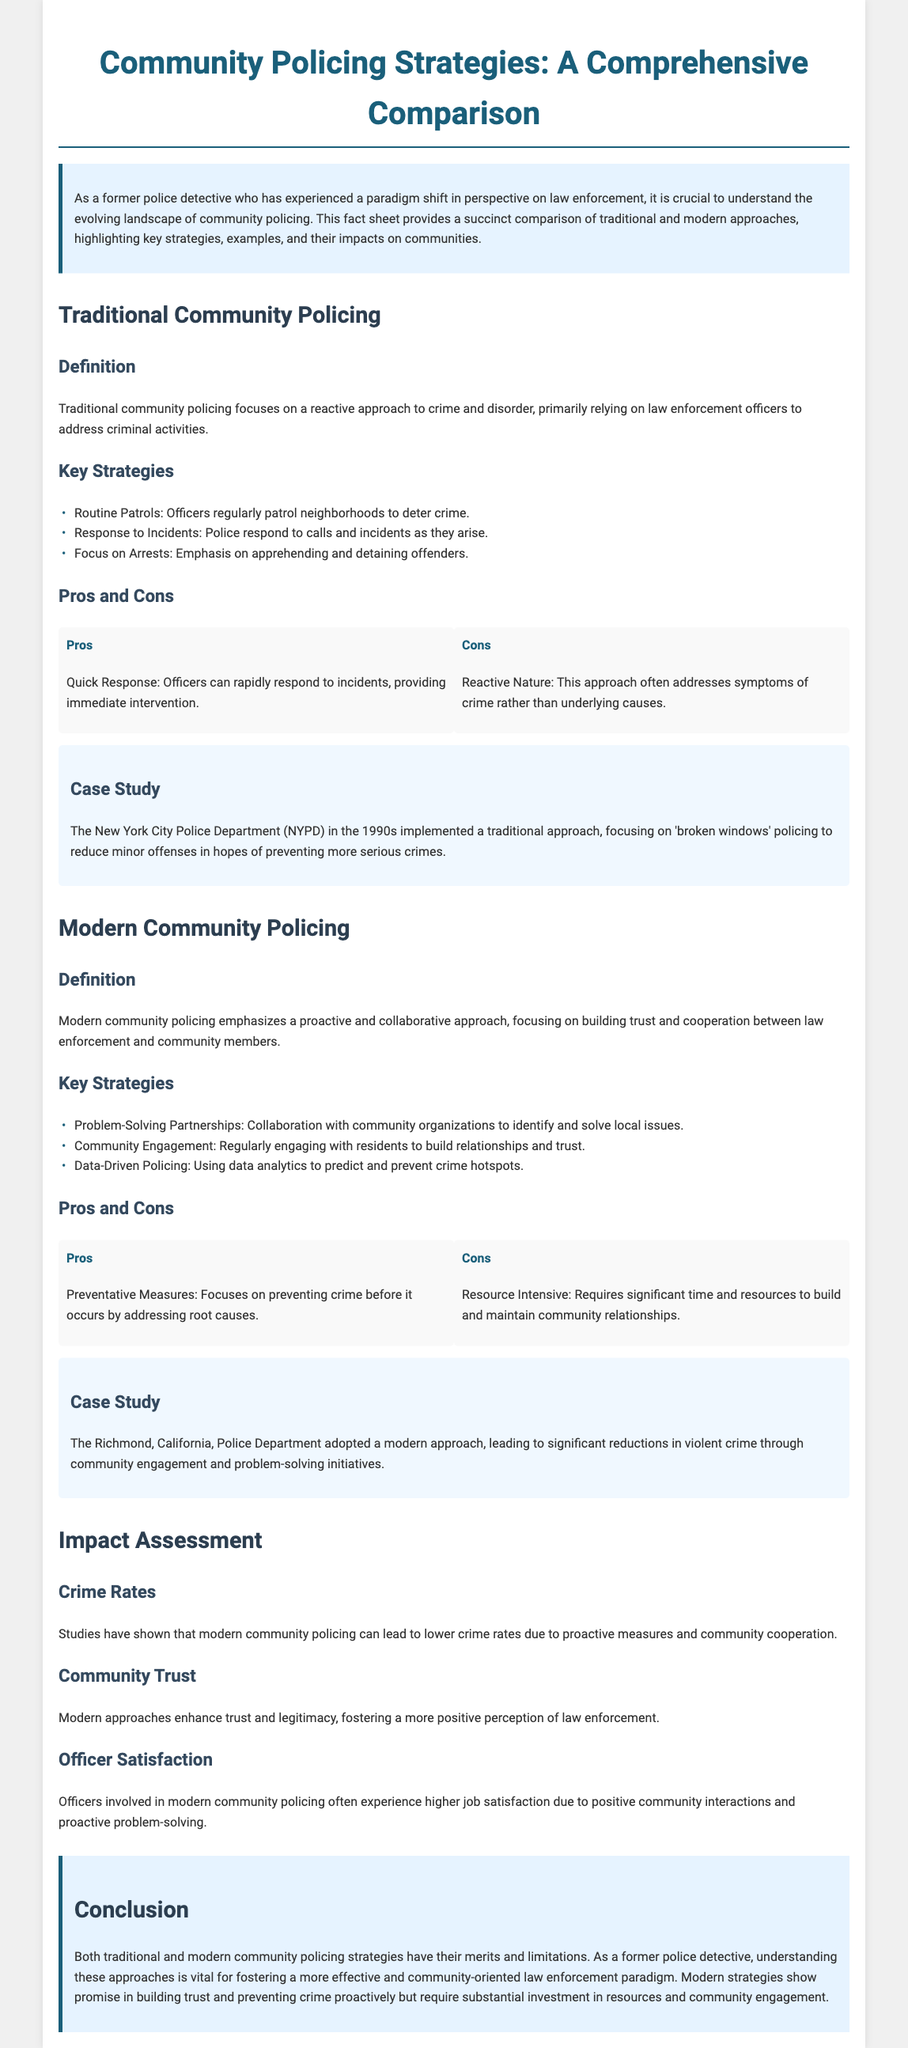What is the primary focus of traditional community policing? Traditional community policing primarily relies on law enforcement officers to address criminal activities, representing a reactive approach.
Answer: Reactive approach What is one key strategy of modern community policing? One of the key strategies is "Problem-Solving Partnerships," which involves collaborating with community organizations to identify and solve local issues.
Answer: Problem-Solving Partnerships What year did the NYPD implement a traditional approach to policing? The document references the NYPD's traditional approach implemented in the 1990s, focusing on 'broken windows' policing.
Answer: 1990s What is a pro of modern community policing? A pro of modern community policing is its focus on preventative measures, addressing root causes of crime.
Answer: Preventative measures Which city's police department adopted a modern approach leading to crime reduction? The Richmond, California, Police Department adopted a modern approach that significantly reduced violent crime through community engagement and problem-solving initiatives.
Answer: Richmond, California What are the two main aspects assessed in the impact assessment section? The impact assessment section examines crime rates and community trust, showcasing the effects of modern community policing.
Answer: Crime rates, community trust What is a con of traditional community policing? A con of traditional community policing is that it has a reactive nature, often addressing symptoms of crime rather than underlying causes.
Answer: Reactive nature How does modern community policing affect officer satisfaction? Officers involved in modern community policing often experience higher job satisfaction due to positive community interactions and proactive problem-solving.
Answer: Higher job satisfaction 